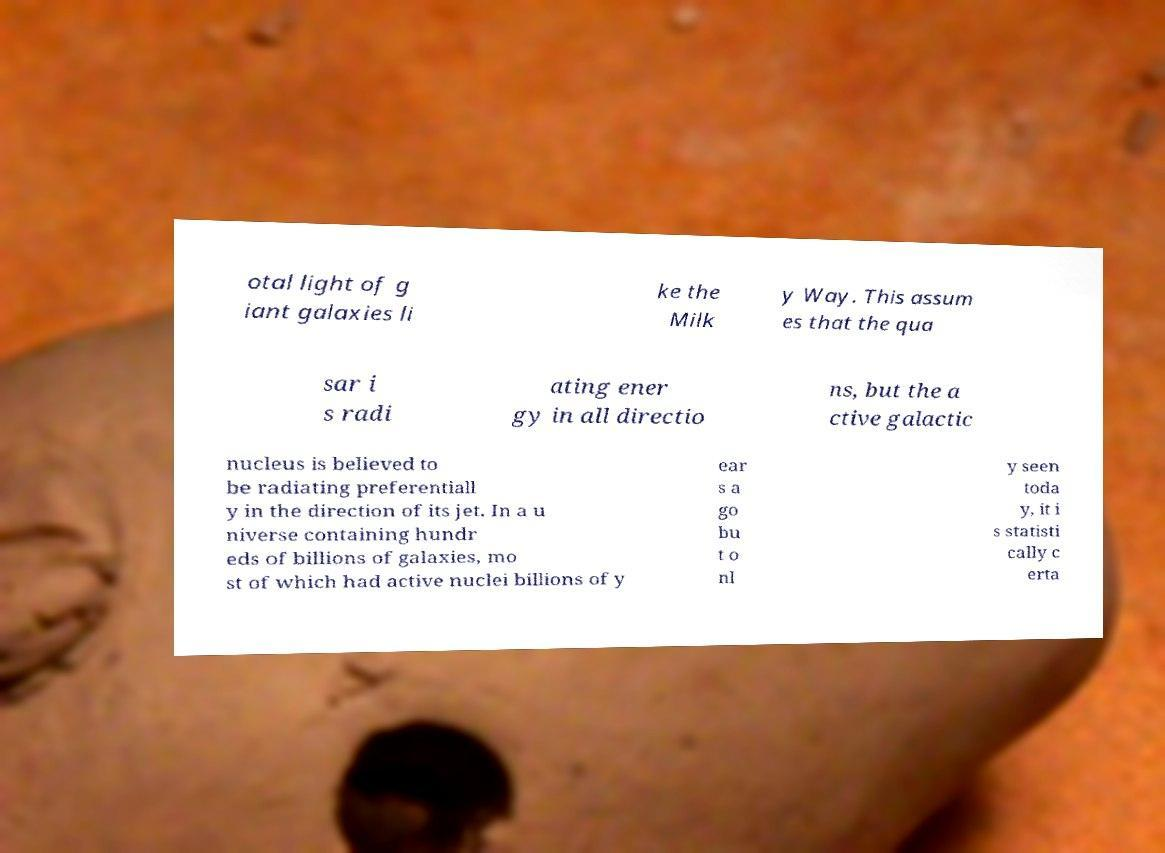I need the written content from this picture converted into text. Can you do that? otal light of g iant galaxies li ke the Milk y Way. This assum es that the qua sar i s radi ating ener gy in all directio ns, but the a ctive galactic nucleus is believed to be radiating preferentiall y in the direction of its jet. In a u niverse containing hundr eds of billions of galaxies, mo st of which had active nuclei billions of y ear s a go bu t o nl y seen toda y, it i s statisti cally c erta 